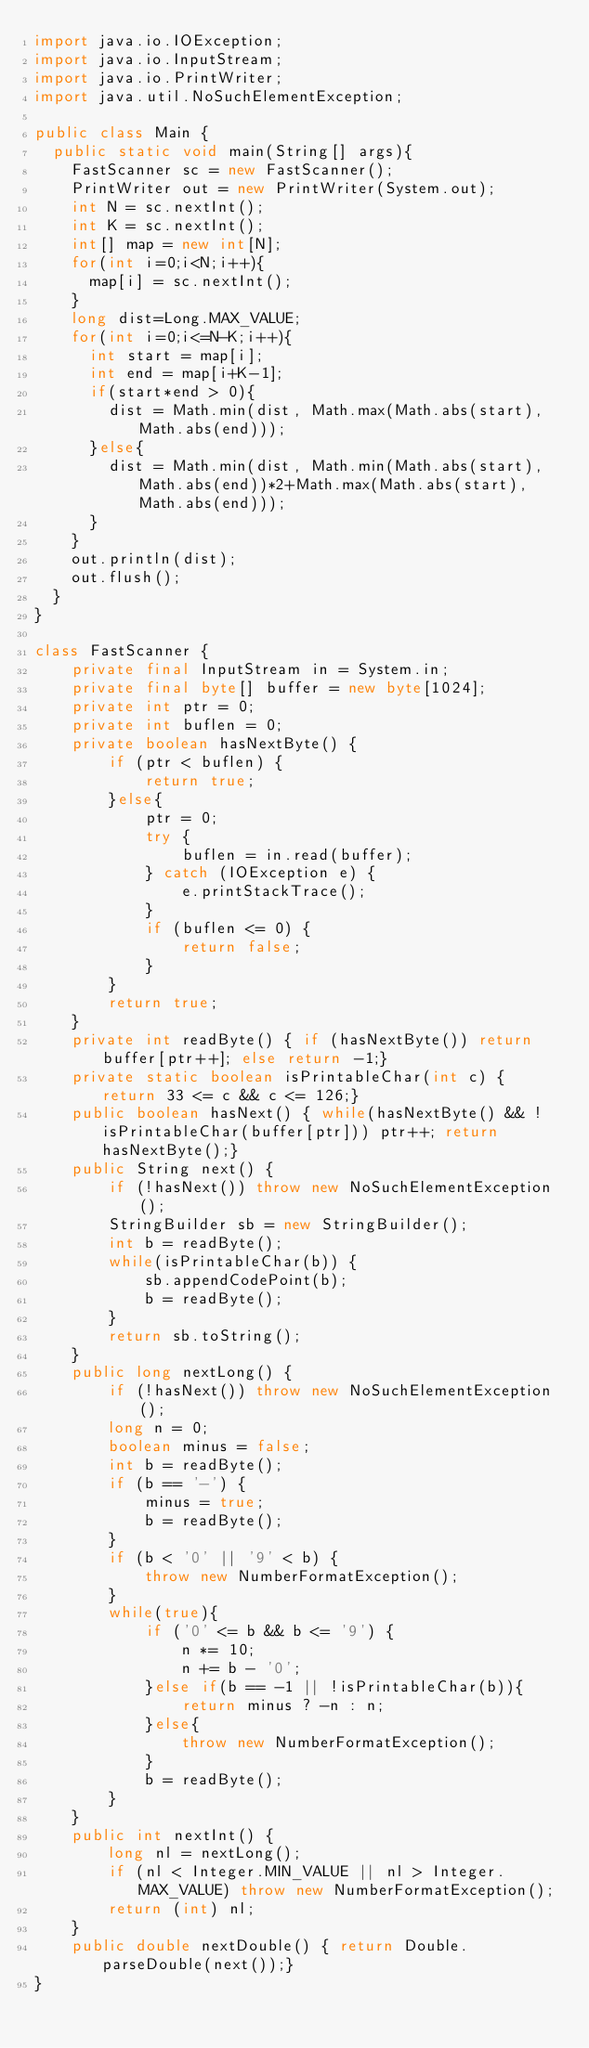<code> <loc_0><loc_0><loc_500><loc_500><_Java_>import java.io.IOException;
import java.io.InputStream;
import java.io.PrintWriter;
import java.util.NoSuchElementException;

public class Main {
	public static void main(String[] args){
		FastScanner sc = new FastScanner();
		PrintWriter out = new PrintWriter(System.out);
		int N = sc.nextInt();
		int K = sc.nextInt();
		int[] map = new int[N];
		for(int i=0;i<N;i++){
			map[i] = sc.nextInt();
		}
		long dist=Long.MAX_VALUE;
		for(int i=0;i<=N-K;i++){
			int start = map[i];
			int end = map[i+K-1];
			if(start*end > 0){
				dist = Math.min(dist, Math.max(Math.abs(start), Math.abs(end)));
			}else{
				dist = Math.min(dist, Math.min(Math.abs(start), Math.abs(end))*2+Math.max(Math.abs(start), Math.abs(end)));
			}
		}
		out.println(dist);
		out.flush();
	}
}

class FastScanner {
    private final InputStream in = System.in;
    private final byte[] buffer = new byte[1024];
    private int ptr = 0;
    private int buflen = 0;
    private boolean hasNextByte() {
        if (ptr < buflen) {
            return true;
        }else{
            ptr = 0;
            try {
                buflen = in.read(buffer);
            } catch (IOException e) {
                e.printStackTrace();
            }
            if (buflen <= 0) {
                return false;
            }
        }
        return true;
    }
    private int readByte() { if (hasNextByte()) return buffer[ptr++]; else return -1;}
    private static boolean isPrintableChar(int c) { return 33 <= c && c <= 126;}
    public boolean hasNext() { while(hasNextByte() && !isPrintableChar(buffer[ptr])) ptr++; return hasNextByte();}
    public String next() {
        if (!hasNext()) throw new NoSuchElementException();
        StringBuilder sb = new StringBuilder();
        int b = readByte();
        while(isPrintableChar(b)) {
            sb.appendCodePoint(b);
            b = readByte();
        }
        return sb.toString();
    }
    public long nextLong() {
        if (!hasNext()) throw new NoSuchElementException();
        long n = 0;
        boolean minus = false;
        int b = readByte();
        if (b == '-') {
            minus = true;
            b = readByte();
        }
        if (b < '0' || '9' < b) {
            throw new NumberFormatException();
        }
        while(true){
            if ('0' <= b && b <= '9') {
                n *= 10;
                n += b - '0';
            }else if(b == -1 || !isPrintableChar(b)){
                return minus ? -n : n;
            }else{
                throw new NumberFormatException();
            }
            b = readByte();
        }
    }
    public int nextInt() {
        long nl = nextLong();
        if (nl < Integer.MIN_VALUE || nl > Integer.MAX_VALUE) throw new NumberFormatException();
        return (int) nl;
    }
    public double nextDouble() { return Double.parseDouble(next());}
}</code> 